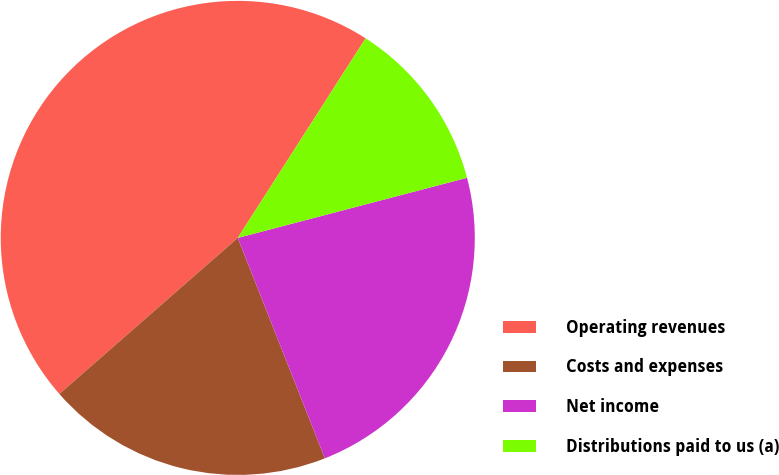Convert chart. <chart><loc_0><loc_0><loc_500><loc_500><pie_chart><fcel>Operating revenues<fcel>Costs and expenses<fcel>Net income<fcel>Distributions paid to us (a)<nl><fcel>45.5%<fcel>19.55%<fcel>23.09%<fcel>11.85%<nl></chart> 